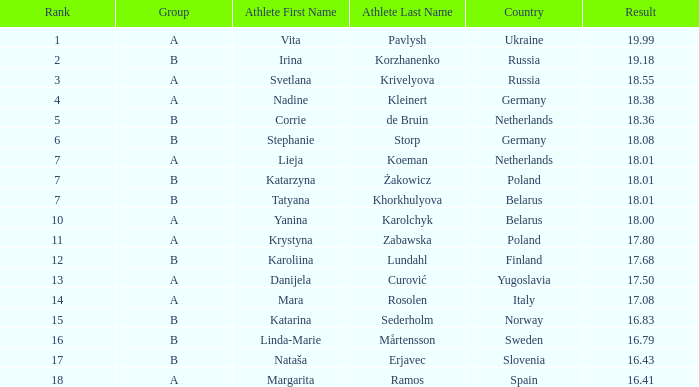Which athlete, has an 18.55 result Svetlana Krivelyova. 